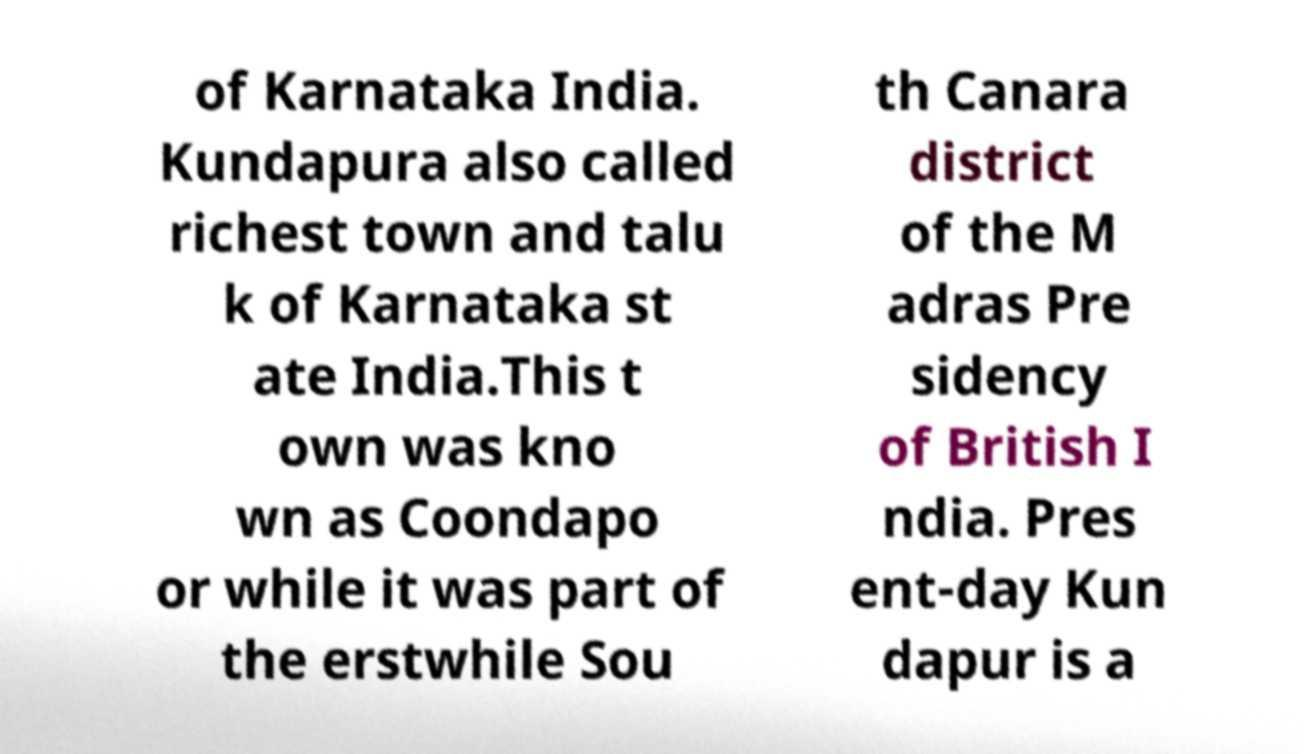Can you accurately transcribe the text from the provided image for me? of Karnataka India. Kundapura also called richest town and talu k of Karnataka st ate India.This t own was kno wn as Coondapo or while it was part of the erstwhile Sou th Canara district of the M adras Pre sidency of British I ndia. Pres ent-day Kun dapur is a 